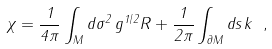<formula> <loc_0><loc_0><loc_500><loc_500>\chi = \frac { 1 } { 4 \pi } \int _ { M } d { \sigma ^ { 2 } } \, g ^ { 1 / 2 } R + \frac { 1 } { 2 \pi } \int _ { \partial M } d s \, k \ ,</formula> 